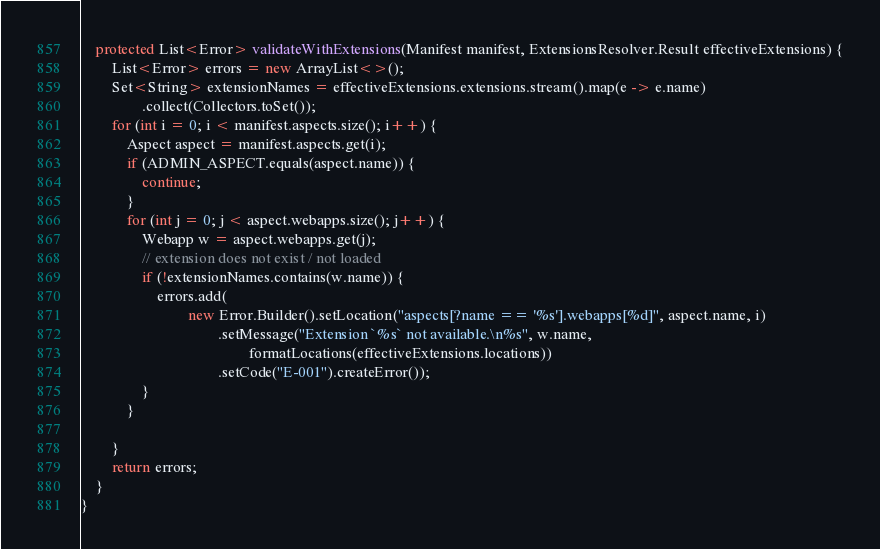<code> <loc_0><loc_0><loc_500><loc_500><_Java_>    protected List<Error> validateWithExtensions(Manifest manifest, ExtensionsResolver.Result effectiveExtensions) {
        List<Error> errors = new ArrayList<>();
        Set<String> extensionNames = effectiveExtensions.extensions.stream().map(e -> e.name)
                .collect(Collectors.toSet());
        for (int i = 0; i < manifest.aspects.size(); i++) {
            Aspect aspect = manifest.aspects.get(i);
            if (ADMIN_ASPECT.equals(aspect.name)) {
                continue;
            }
            for (int j = 0; j < aspect.webapps.size(); j++) {
                Webapp w = aspect.webapps.get(j);
                // extension does not exist / not loaded
                if (!extensionNames.contains(w.name)) {
                    errors.add(
                            new Error.Builder().setLocation("aspects[?name == '%s'].webapps[%d]", aspect.name, i)
                                    .setMessage("Extension `%s` not available.\n%s", w.name,
                                            formatLocations(effectiveExtensions.locations))
                                    .setCode("E-001").createError());
                }
            }

        }
        return errors;
    }
}
</code> 